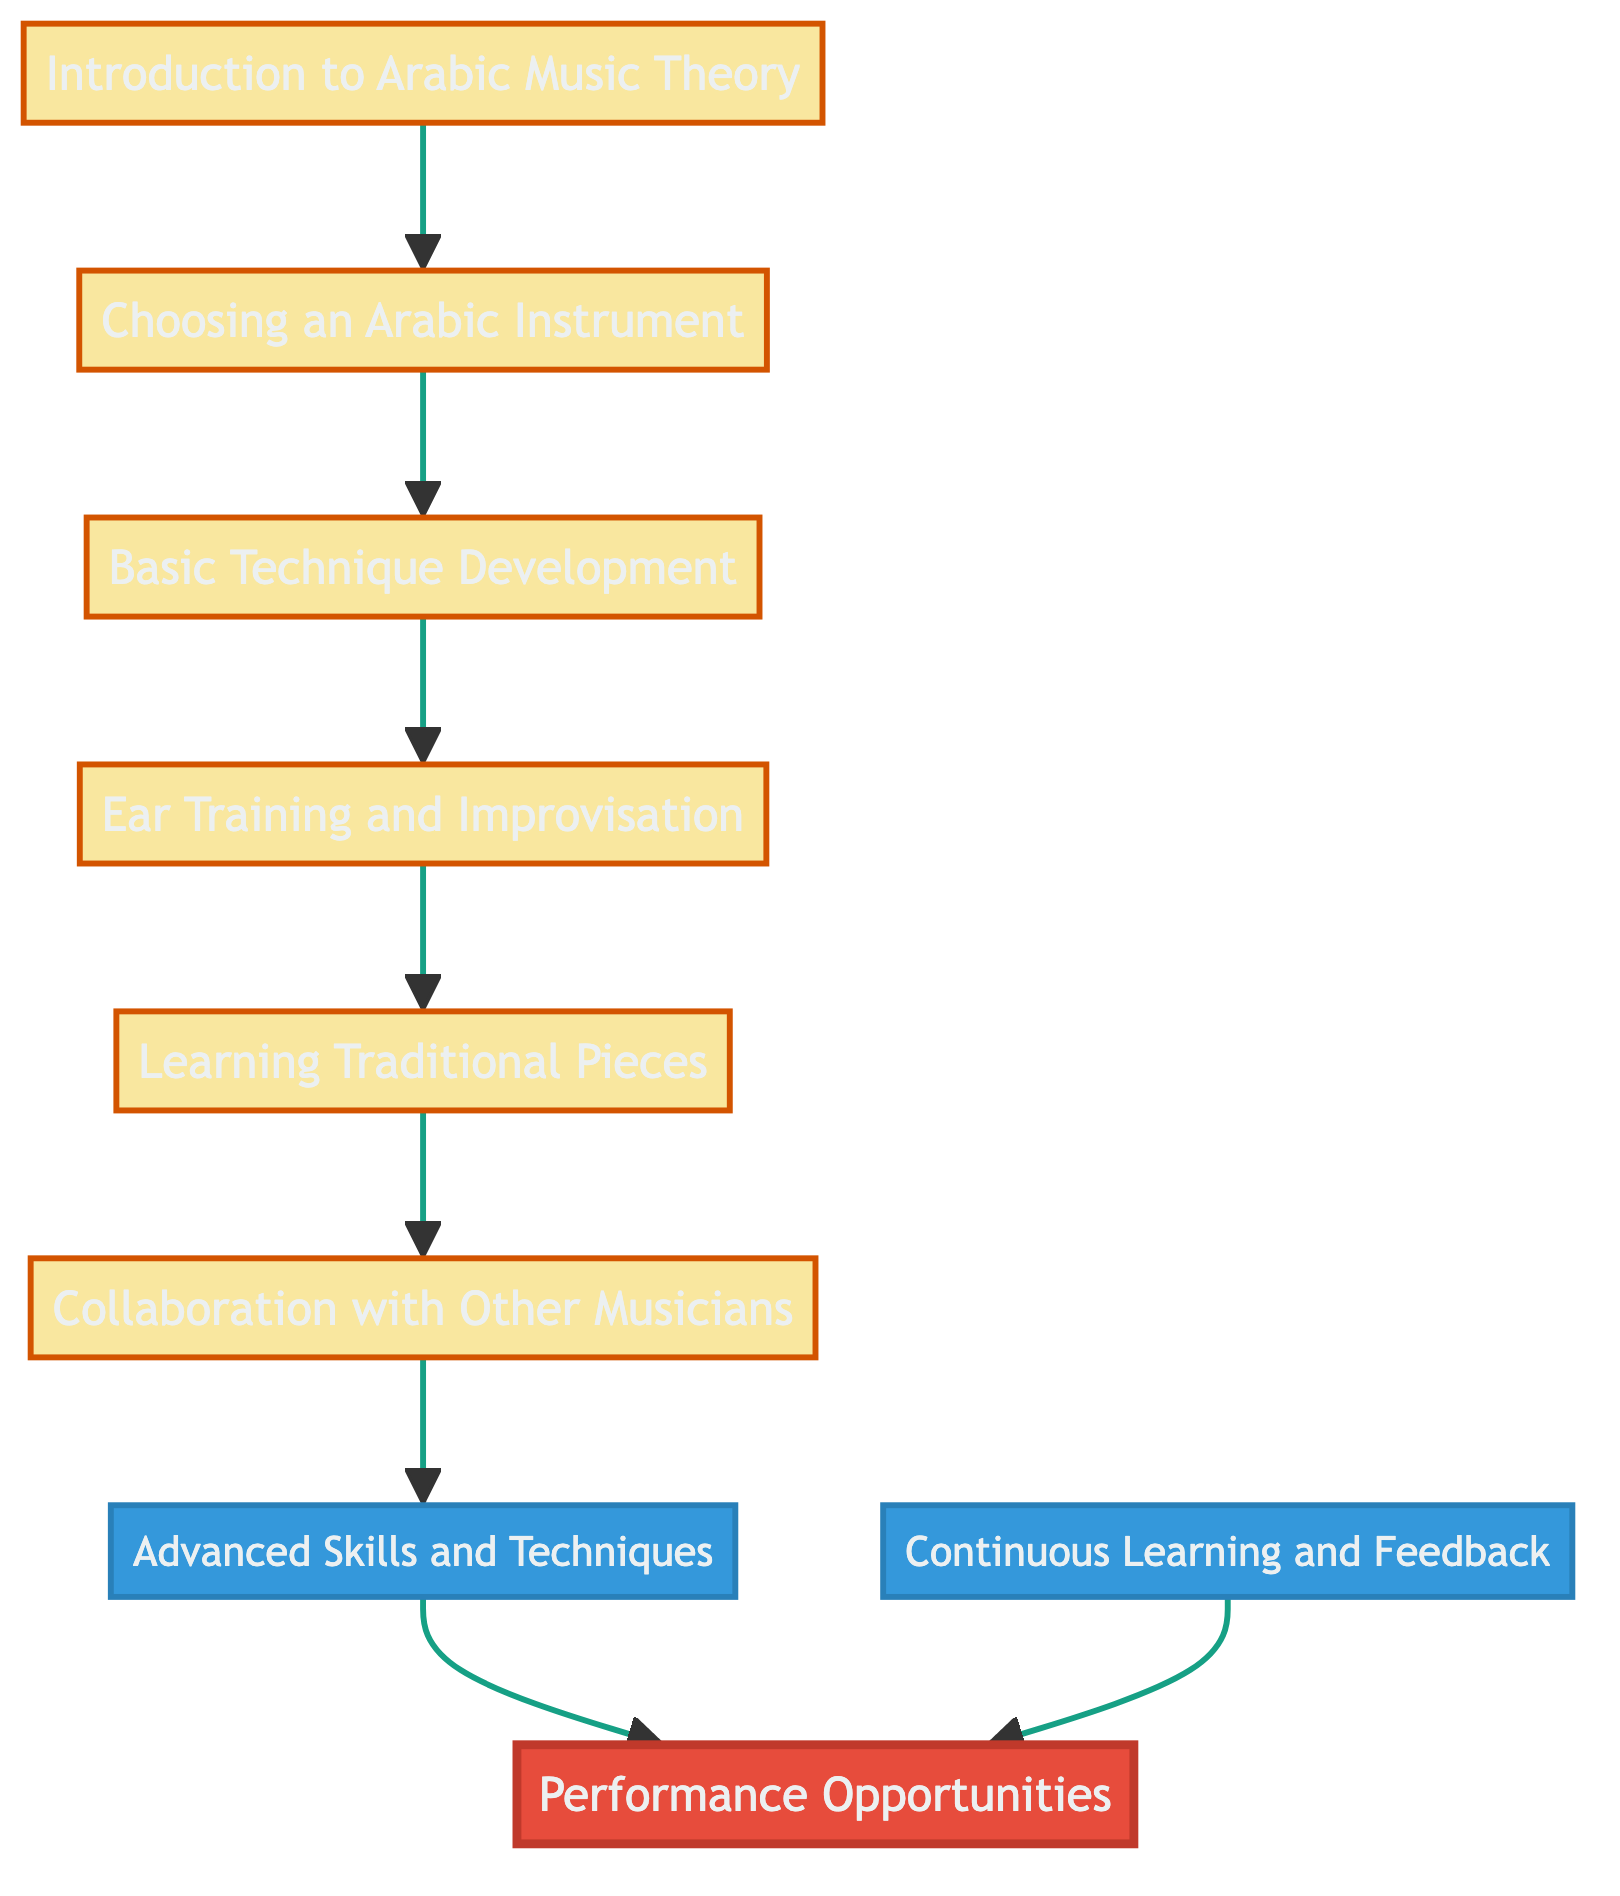What is the first step in mastering an Arabic instrument? The diagram indicates that the first step is "Introduction to Arabic Music Theory." This is shown at the top of the flowchart, indicating that it is the foundational beginning of the learning path.
Answer: Introduction to Arabic Music Theory How many total nodes are there in the diagram? By counting each labeled element (node) in the flowchart, there are a total of 9 distinct elements present, including the root and intermediate nodes.
Answer: 9 What follows the basic technique development in the learning process? The diagram shows that after "Basic Technique Development," the next step is "Ear Training and Improvisation." This is a connection made by a single directed edge below the "Basic Technique Development" node.
Answer: Ear Training and Improvisation Which node leads directly to performance opportunities? There are two nodes that connect to "Performance Opportunities": "Collaboration with Other Musicians" and "Continuous Learning and Feedback." This relationship is outlined in the lower section of the diagram where arrows directly point towards the performance node.
Answer: Collaboration with Other Musicians, Continuous Learning and Feedback How does the concept of "Continuous Learning and Feedback" relate to performance opportunities? The flowchart illustrates that "Continuous Learning and Feedback" is one of the aspects that leads directly to "Performance Opportunities." This indicates that ongoing education and input can enhance performance skills, highlighting the importance of continuous improvement.
Answer: It leads directly to performance opportunities What element comes before learning traditional pieces? According to the diagram, "Ear Training and Improvisation" precedes "Learning Traditional Pieces." This relationship demonstrates a prerequisite skill set before moving to traditional compositions.
Answer: Ear Training and Improvisation Which nodes are considered intermediate skills in this diagram? The intermediate nodes are highlighted in blue and include "Advanced Skills and Techniques," "Continuous Learning and Feedback," and "Collaboration with Other Musicians." These nodes indicate development beyond basic skills towards performance readiness.
Answer: Advanced Skills and Techniques, Continuous Learning and Feedback, Collaboration with Other Musicians What is the relationship visualized between "Learning Traditional Pieces" and "Collaboration with Other Musicians"? The flowchart illustrates that "Learning Traditional Pieces" leads directly to "Collaboration with Other Musicians." This shows that acquiring traditional pieces enhances the ability to collaborate effectively in an ensemble context.
Answer: Learning Traditional Pieces leads to Collaboration with Other Musicians Which stage is essential before reaching "Advanced Skills and Techniques"? The necessary stage before advancing to "Advanced Skills and Techniques" is "Collaboration with Other Musicians." This reflects that collaborating becomes critical for skill enhancement prior to tackling more complex techniques.
Answer: Collaboration with Other Musicians 